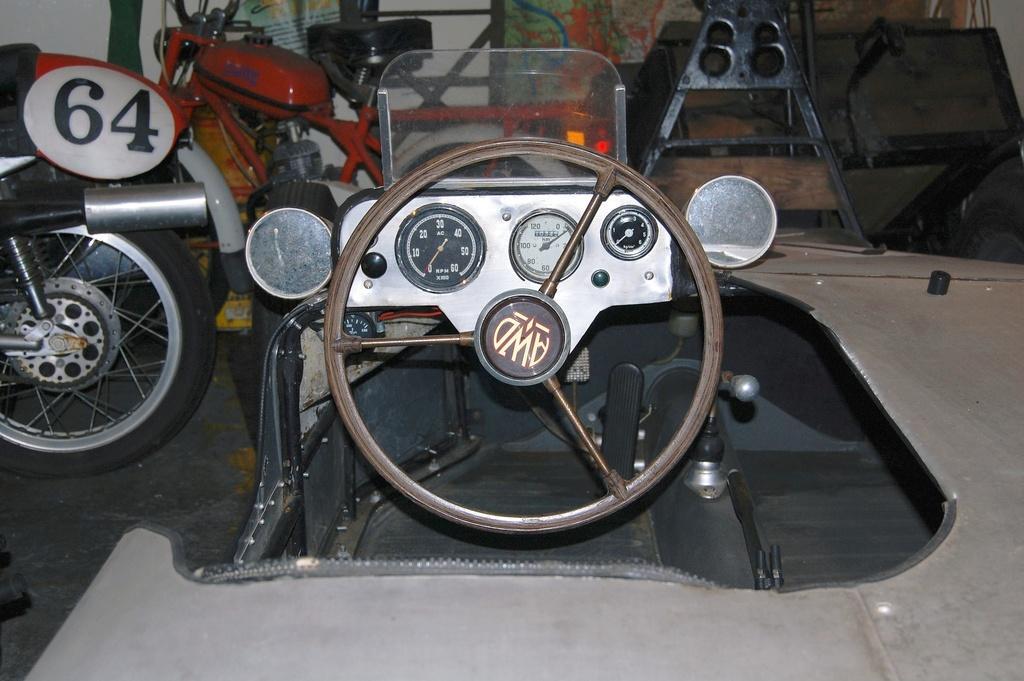Describe this image in one or two sentences. In this picture, we can see a few vehicles, and we can see some objects in the top right corner, and we can see the ground, and the wall. 